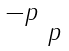<formula> <loc_0><loc_0><loc_500><loc_500>\begin{smallmatrix} - p & \\ & p \end{smallmatrix}</formula> 